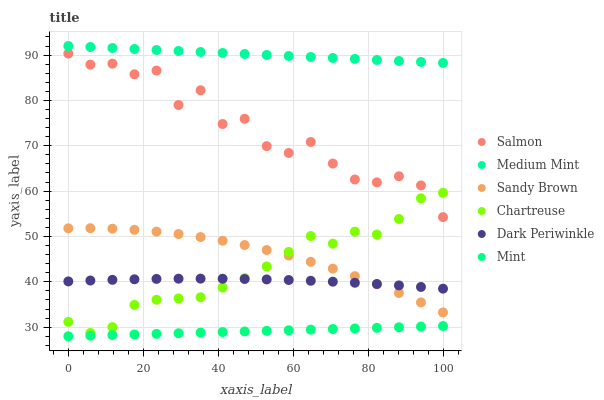Does Mint have the minimum area under the curve?
Answer yes or no. Yes. Does Medium Mint have the maximum area under the curve?
Answer yes or no. Yes. Does Salmon have the minimum area under the curve?
Answer yes or no. No. Does Salmon have the maximum area under the curve?
Answer yes or no. No. Is Mint the smoothest?
Answer yes or no. Yes. Is Salmon the roughest?
Answer yes or no. Yes. Is Salmon the smoothest?
Answer yes or no. No. Is Mint the roughest?
Answer yes or no. No. Does Mint have the lowest value?
Answer yes or no. Yes. Does Salmon have the lowest value?
Answer yes or no. No. Does Medium Mint have the highest value?
Answer yes or no. Yes. Does Salmon have the highest value?
Answer yes or no. No. Is Salmon less than Medium Mint?
Answer yes or no. Yes. Is Dark Periwinkle greater than Mint?
Answer yes or no. Yes. Does Sandy Brown intersect Chartreuse?
Answer yes or no. Yes. Is Sandy Brown less than Chartreuse?
Answer yes or no. No. Is Sandy Brown greater than Chartreuse?
Answer yes or no. No. Does Salmon intersect Medium Mint?
Answer yes or no. No. 